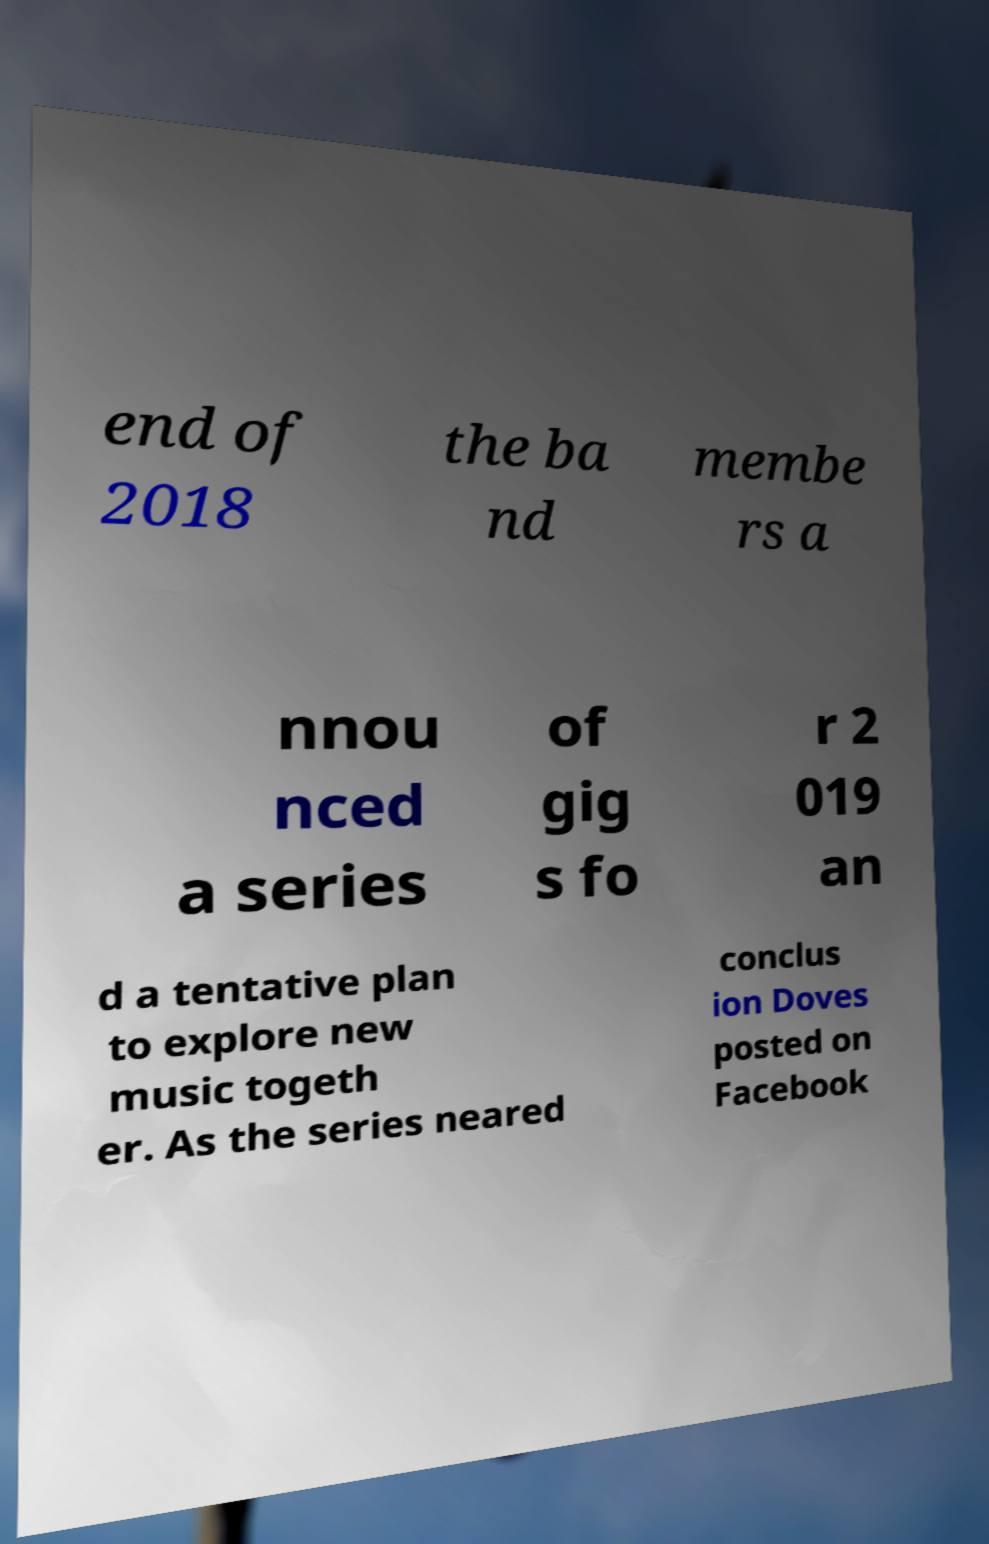Please identify and transcribe the text found in this image. end of 2018 the ba nd membe rs a nnou nced a series of gig s fo r 2 019 an d a tentative plan to explore new music togeth er. As the series neared conclus ion Doves posted on Facebook 